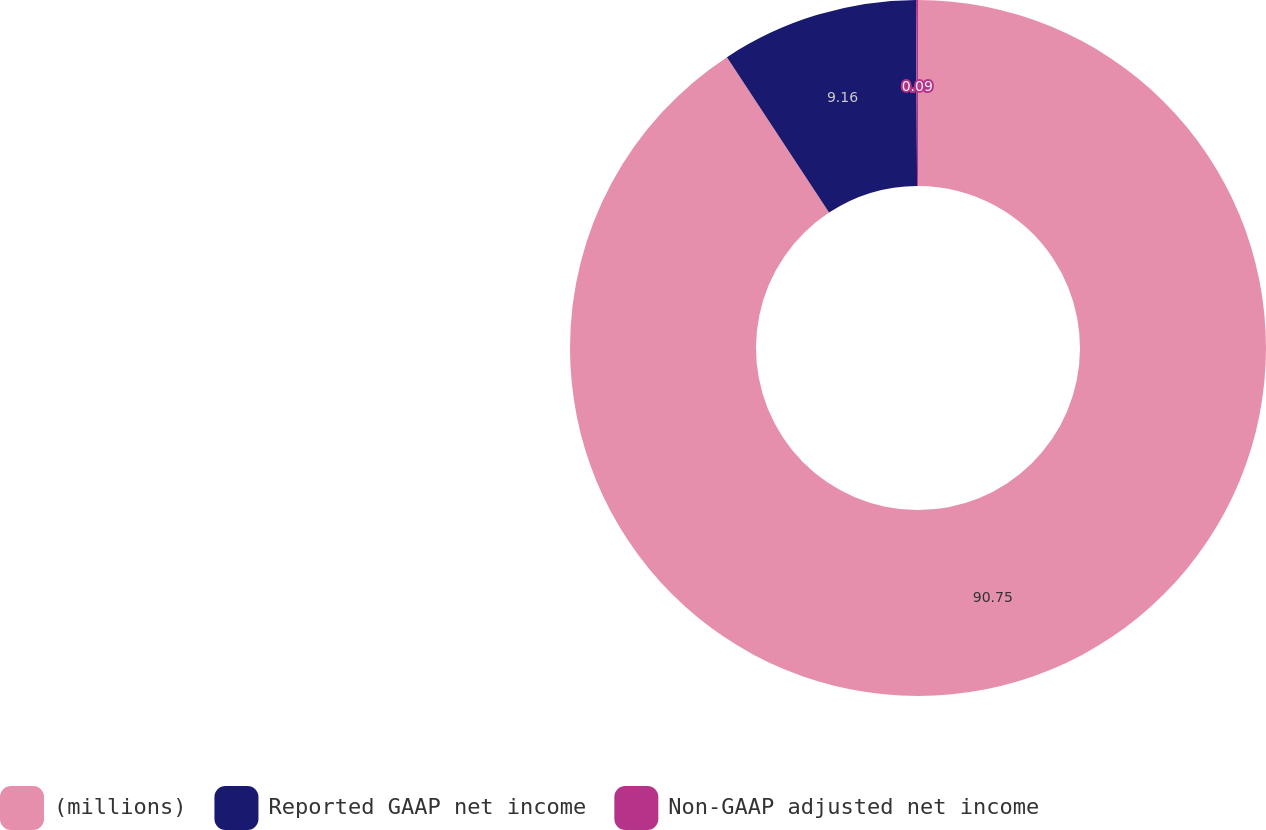<chart> <loc_0><loc_0><loc_500><loc_500><pie_chart><fcel>(millions)<fcel>Reported GAAP net income<fcel>Non-GAAP adjusted net income<nl><fcel>90.75%<fcel>9.16%<fcel>0.09%<nl></chart> 